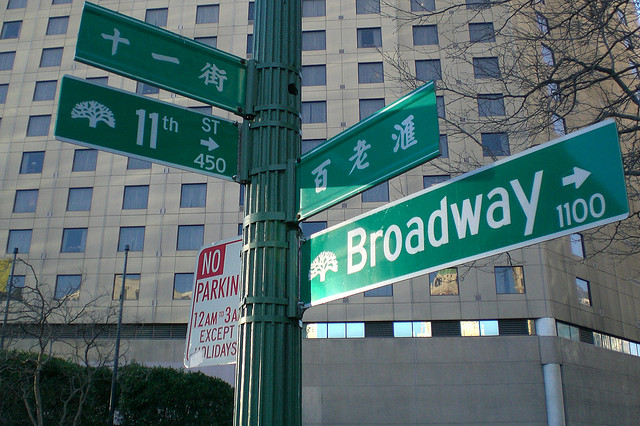Please extract the text content from this image. Broadway 1100 11 th ST 450 NO PARKIN EXCEPT HOLIDAYS 3 A.M. 12 